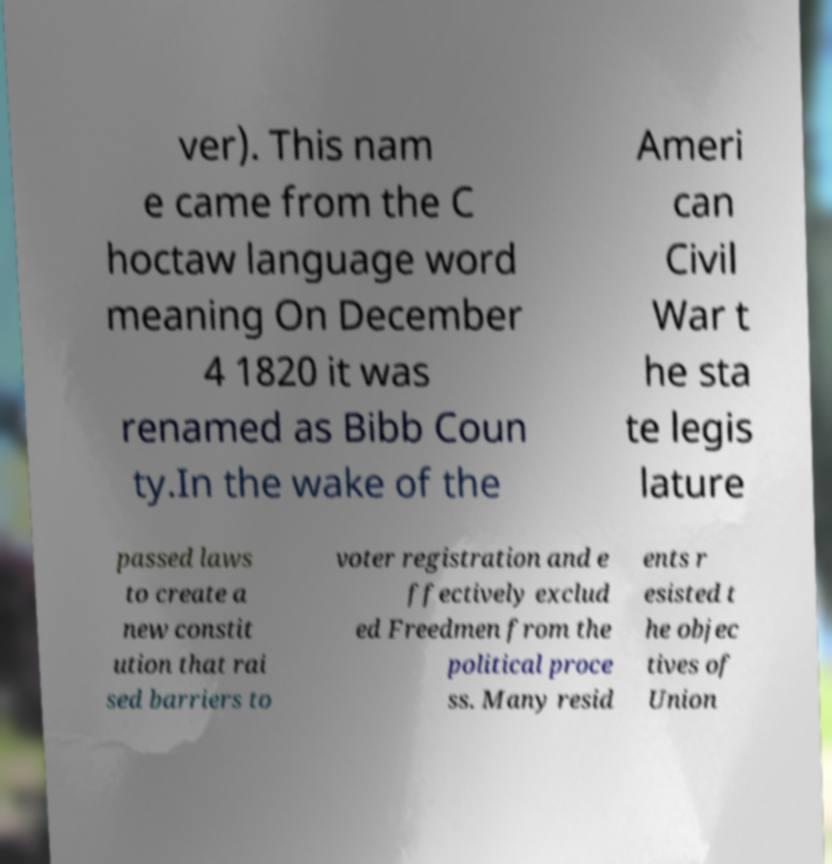There's text embedded in this image that I need extracted. Can you transcribe it verbatim? ver). This nam e came from the C hoctaw language word meaning On December 4 1820 it was renamed as Bibb Coun ty.In the wake of the Ameri can Civil War t he sta te legis lature passed laws to create a new constit ution that rai sed barriers to voter registration and e ffectively exclud ed Freedmen from the political proce ss. Many resid ents r esisted t he objec tives of Union 